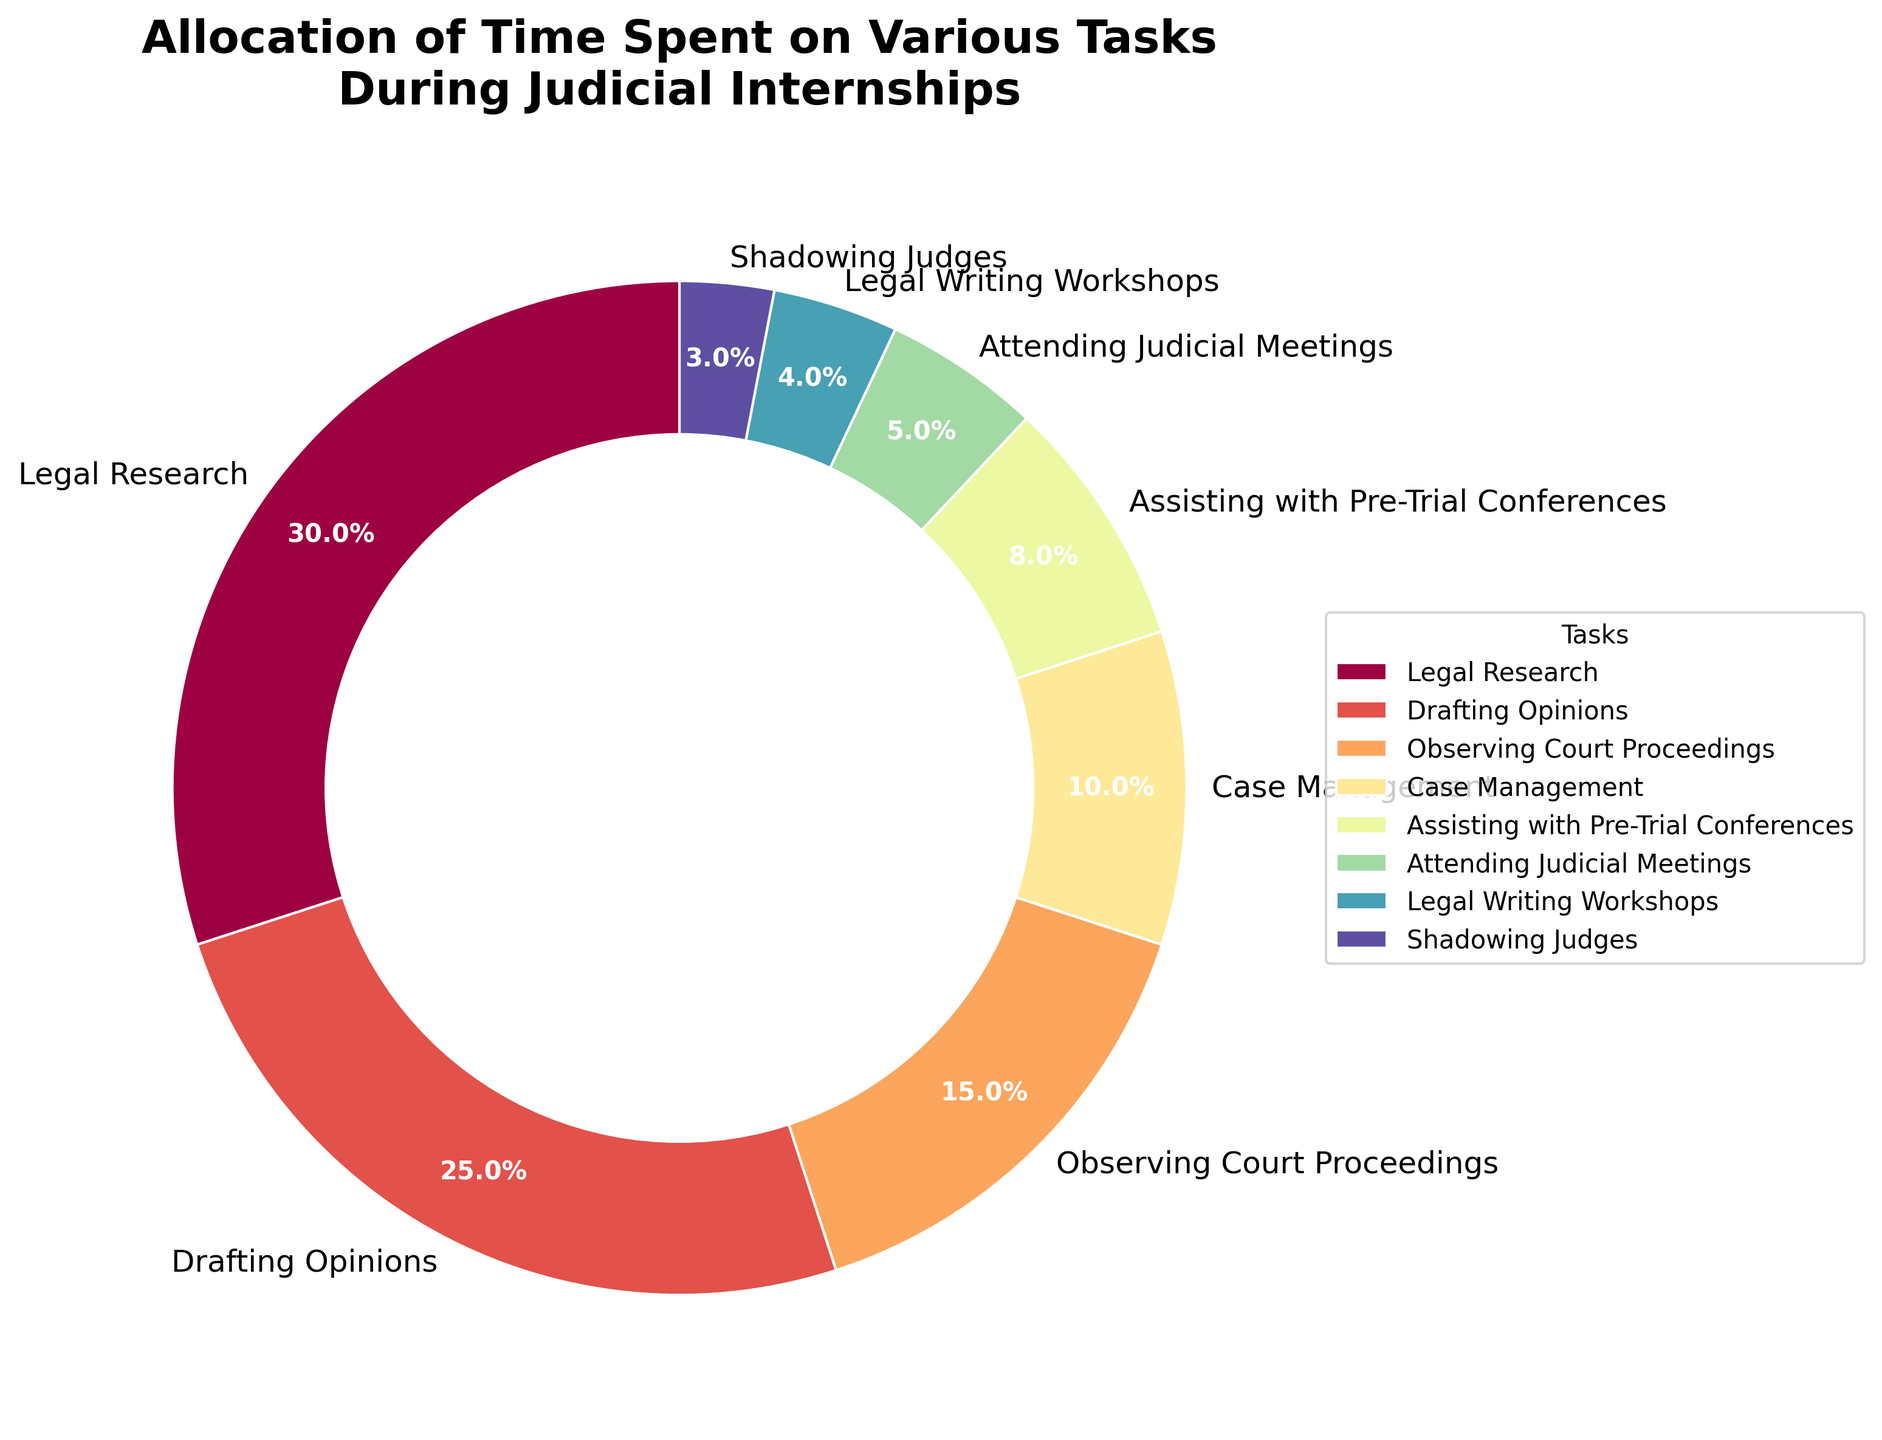Which task takes up the most time during judicial internships? By visually inspecting the pie chart, the largest wedge corresponds to "Legal Research" which has a percentage label of 30%.
Answer: Legal Research What is the combined percentage for Drafting Opinions and Observing Court Proceedings? To find this, add the percentage for Drafting Opinions (25%) and Observing Court Proceedings (15%). So, 25% + 15% = 40%.
Answer: 40% Which tasks together constitute half of the total internship time? The tasks and their percentages sum up to 100%. The largest wedges (which add up to 50%) are “Legal Research” (30%) and “Drafting Opinions” (25%). However, 30% + 25% = 55%, hence we’ll need to include a smaller task to balance to 50%. Adding “Legal Research” (30%) and “Observing Court Proceedings” (15%) gives 45%. Adding one smaller task, such as “Case Management” (10%) makes it 55%. We need to resort to including another smaller activity to make it more precise.
Answer: Legal Research, Drafting Opinions, Observing Court Proceedings Which is greater: the time allocated for Assisting with Pre-Trial Conferences or the total time for Shadowing Judges and Attending Judicial Meetings? Assisting with Pre-Trial Conferences takes 8% of the time. Shadowing Judges is allocated 3%, and Attending Judicial Meetings is 5%. Adding these together: 3% + 5% = 8%, which is equal to the percentage for Assisting with Pre-Trial Conferences.
Answer: They are equal How much more time is spent on Legal Writing Workshops than on Shadowing Judges? Legal Writing Workshops takes 4% of the time, while Shadowing Judges takes 3%. The difference is 4% - 3% = 1%.
Answer: 1% What is the smallest task allocation listed on the chart? The smallest wedge visually belongs to "Shadowing Judges," which has a label of 3%.
Answer: Shadowing Judges How does the time allocated to Case Management compare with Assisting with Pre-Trial Conferences? Case Management allocates 10%, and Assisting with Pre-Trial Conferences allocates 8%. By comparing these two values, 10% is greater than 8%.
Answer: Case Management is greater If time for Drafting Opinions were reduced by half, how much total time would the remaining Drafting Opinions task occupy? The current allocation for Drafting Opinions is 25%. Reducing this by half: 25% / 2 = 12.5%. Thus, the remaining time for Drafting Opinions would be 12.5%.
Answer: 12.5% What percentage of time is allocated to tasks specifically involving interaction with judges (including Pre-Trial Conferences, Attending Judicial Meetings, and Shadowing Judges)? Adding the time spent on Assisting with Pre-Trial Conferences (8%), Attending Judicial Meetings (5%), and Shadowing Judges (3%). So, 8% + 5% + 3% = 16%.
Answer: 16% What portion of the internship tasks is not directly involved with court proceedings (everything except Observing Court Proceedings)? To find this, subtract the percentage of Observing Court Proceedings (15%) from 100%. So, 100% - 15% = 85%.
Answer: 85% 